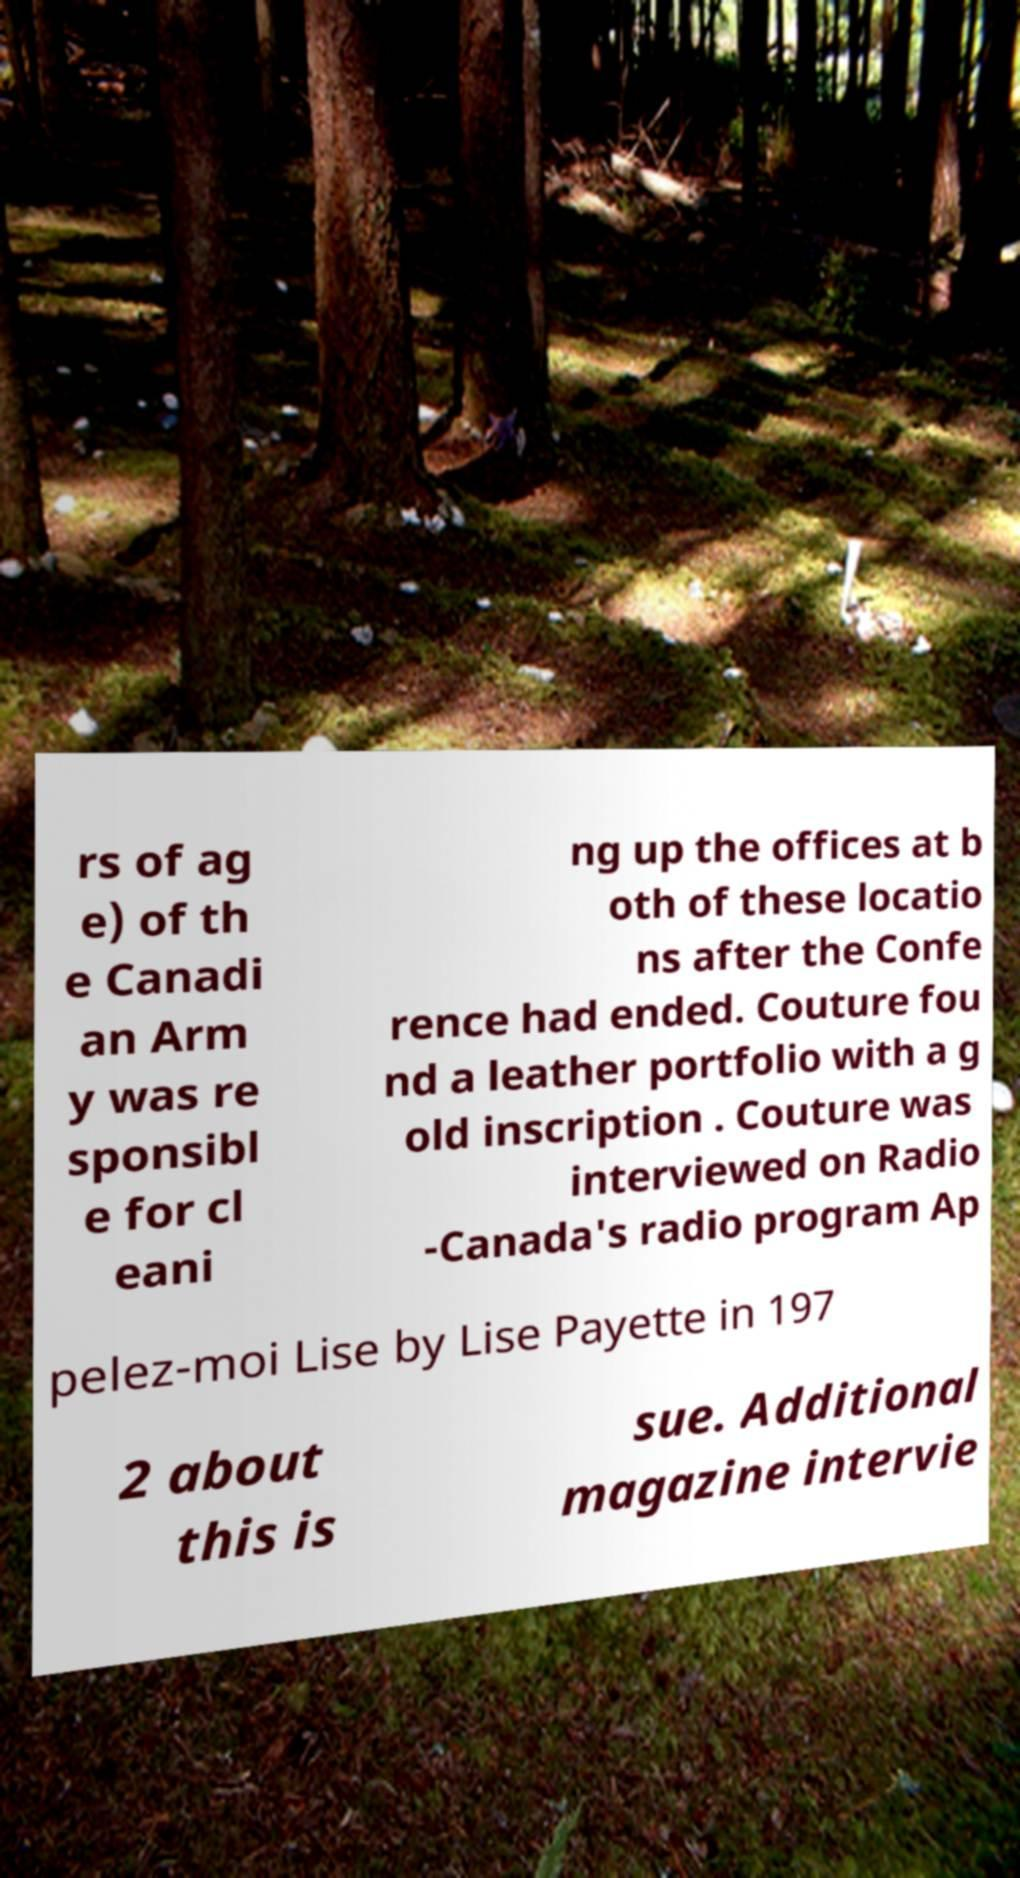Could you assist in decoding the text presented in this image and type it out clearly? rs of ag e) of th e Canadi an Arm y was re sponsibl e for cl eani ng up the offices at b oth of these locatio ns after the Confe rence had ended. Couture fou nd a leather portfolio with a g old inscription . Couture was interviewed on Radio -Canada's radio program Ap pelez-moi Lise by Lise Payette in 197 2 about this is sue. Additional magazine intervie 